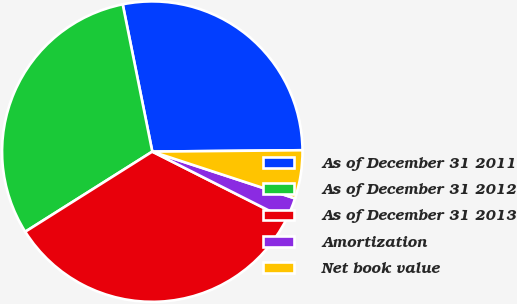Convert chart. <chart><loc_0><loc_0><loc_500><loc_500><pie_chart><fcel>As of December 31 2011<fcel>As of December 31 2012<fcel>As of December 31 2013<fcel>Amortization<fcel>Net book value<nl><fcel>28.01%<fcel>30.8%<fcel>33.6%<fcel>2.4%<fcel>5.19%<nl></chart> 